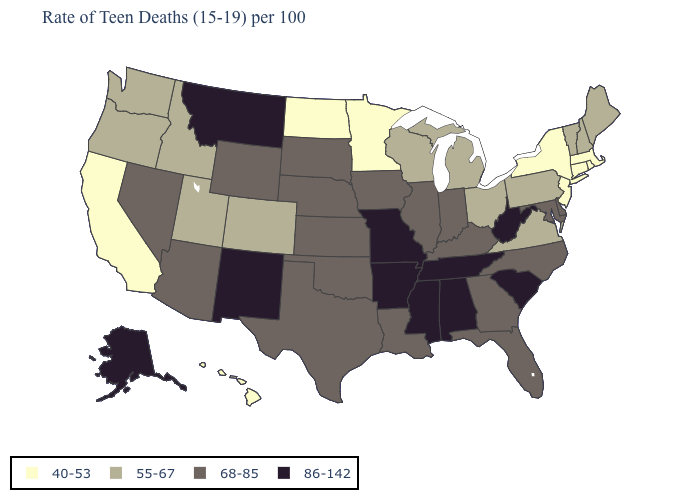Does Tennessee have the same value as Arkansas?
Answer briefly. Yes. Which states have the highest value in the USA?
Be succinct. Alabama, Alaska, Arkansas, Mississippi, Missouri, Montana, New Mexico, South Carolina, Tennessee, West Virginia. Which states have the highest value in the USA?
Give a very brief answer. Alabama, Alaska, Arkansas, Mississippi, Missouri, Montana, New Mexico, South Carolina, Tennessee, West Virginia. What is the value of Colorado?
Quick response, please. 55-67. Does Maryland have a lower value than Oregon?
Be succinct. No. What is the value of Arkansas?
Be succinct. 86-142. Name the states that have a value in the range 40-53?
Give a very brief answer. California, Connecticut, Hawaii, Massachusetts, Minnesota, New Jersey, New York, North Dakota, Rhode Island. Does South Dakota have the lowest value in the USA?
Quick response, please. No. What is the lowest value in states that border South Carolina?
Give a very brief answer. 68-85. What is the lowest value in states that border Florida?
Short answer required. 68-85. What is the highest value in the USA?
Answer briefly. 86-142. Name the states that have a value in the range 68-85?
Concise answer only. Arizona, Delaware, Florida, Georgia, Illinois, Indiana, Iowa, Kansas, Kentucky, Louisiana, Maryland, Nebraska, Nevada, North Carolina, Oklahoma, South Dakota, Texas, Wyoming. Does New Jersey have the highest value in the Northeast?
Concise answer only. No. Name the states that have a value in the range 86-142?
Keep it brief. Alabama, Alaska, Arkansas, Mississippi, Missouri, Montana, New Mexico, South Carolina, Tennessee, West Virginia. How many symbols are there in the legend?
Write a very short answer. 4. 